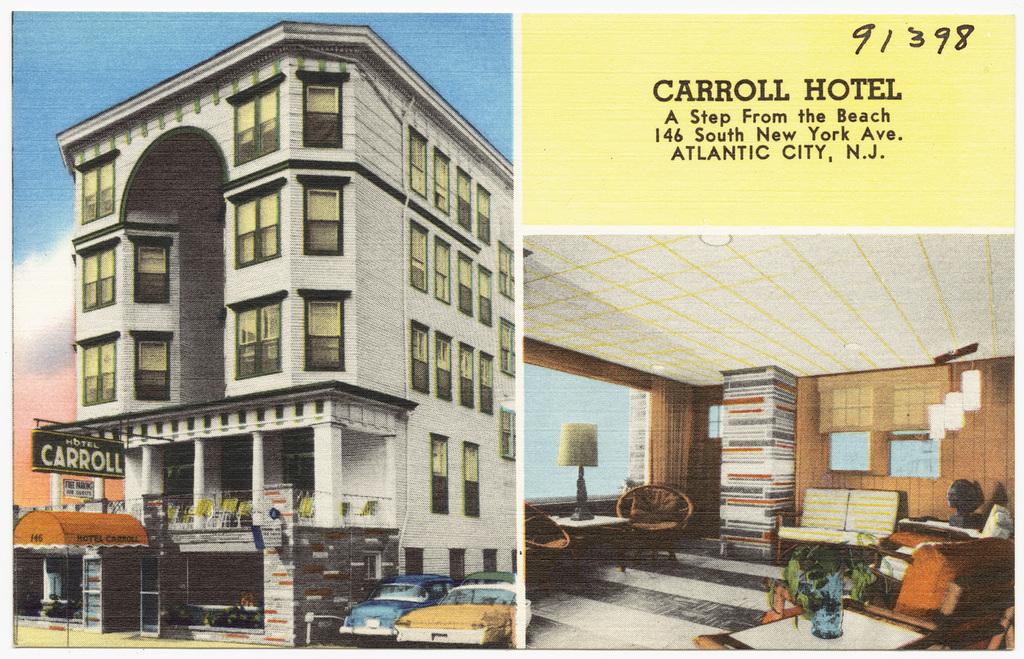What is the address of the carroll hotel?
Provide a short and direct response. 146 south new york ave. How far from the beach is this hotel?
Provide a succinct answer. A step. 